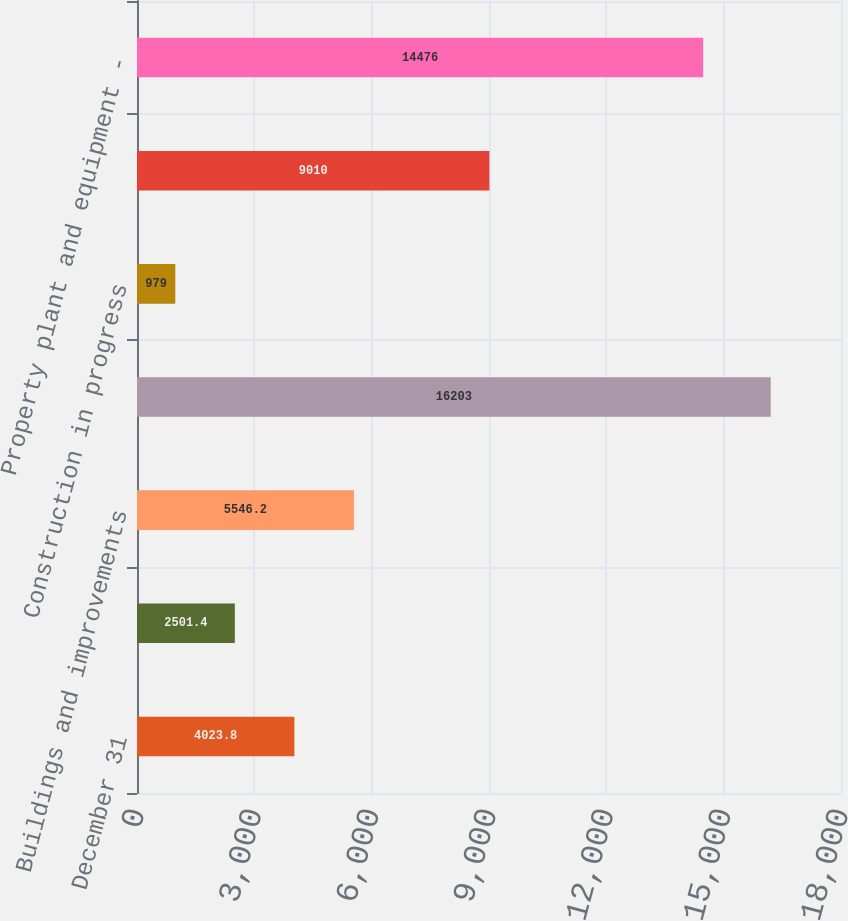<chart> <loc_0><loc_0><loc_500><loc_500><bar_chart><fcel>December 31<fcel>Land<fcel>Buildings and improvements<fcel>Machinery equipment and<fcel>Construction in progress<fcel>Less accumulated depreciation<fcel>Property plant and equipment -<nl><fcel>4023.8<fcel>2501.4<fcel>5546.2<fcel>16203<fcel>979<fcel>9010<fcel>14476<nl></chart> 